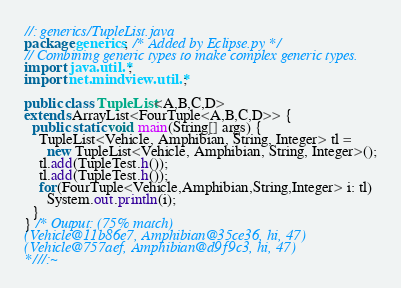Convert code to text. <code><loc_0><loc_0><loc_500><loc_500><_Java_>//: generics/TupleList.java
package generics; /* Added by Eclipse.py */
// Combining generic types to make complex generic types.
import java.util.*;
import net.mindview.util.*;

public class TupleList<A,B,C,D>
extends ArrayList<FourTuple<A,B,C,D>> {
  public static void main(String[] args) {
    TupleList<Vehicle, Amphibian, String, Integer> tl =
      new TupleList<Vehicle, Amphibian, String, Integer>();
    tl.add(TupleTest.h());
    tl.add(TupleTest.h());
    for(FourTuple<Vehicle,Amphibian,String,Integer> i: tl)
      System.out.println(i);
  }
} /* Output: (75% match)
(Vehicle@11b86e7, Amphibian@35ce36, hi, 47)
(Vehicle@757aef, Amphibian@d9f9c3, hi, 47)
*///:~
</code> 